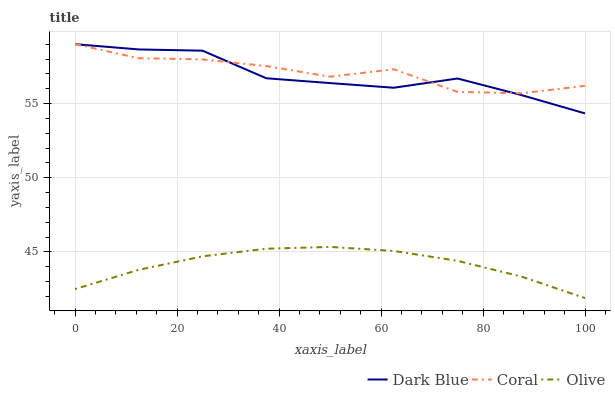Does Dark Blue have the minimum area under the curve?
Answer yes or no. No. Does Dark Blue have the maximum area under the curve?
Answer yes or no. No. Is Dark Blue the smoothest?
Answer yes or no. No. Is Dark Blue the roughest?
Answer yes or no. No. Does Dark Blue have the lowest value?
Answer yes or no. No. Is Olive less than Coral?
Answer yes or no. Yes. Is Dark Blue greater than Olive?
Answer yes or no. Yes. Does Olive intersect Coral?
Answer yes or no. No. 